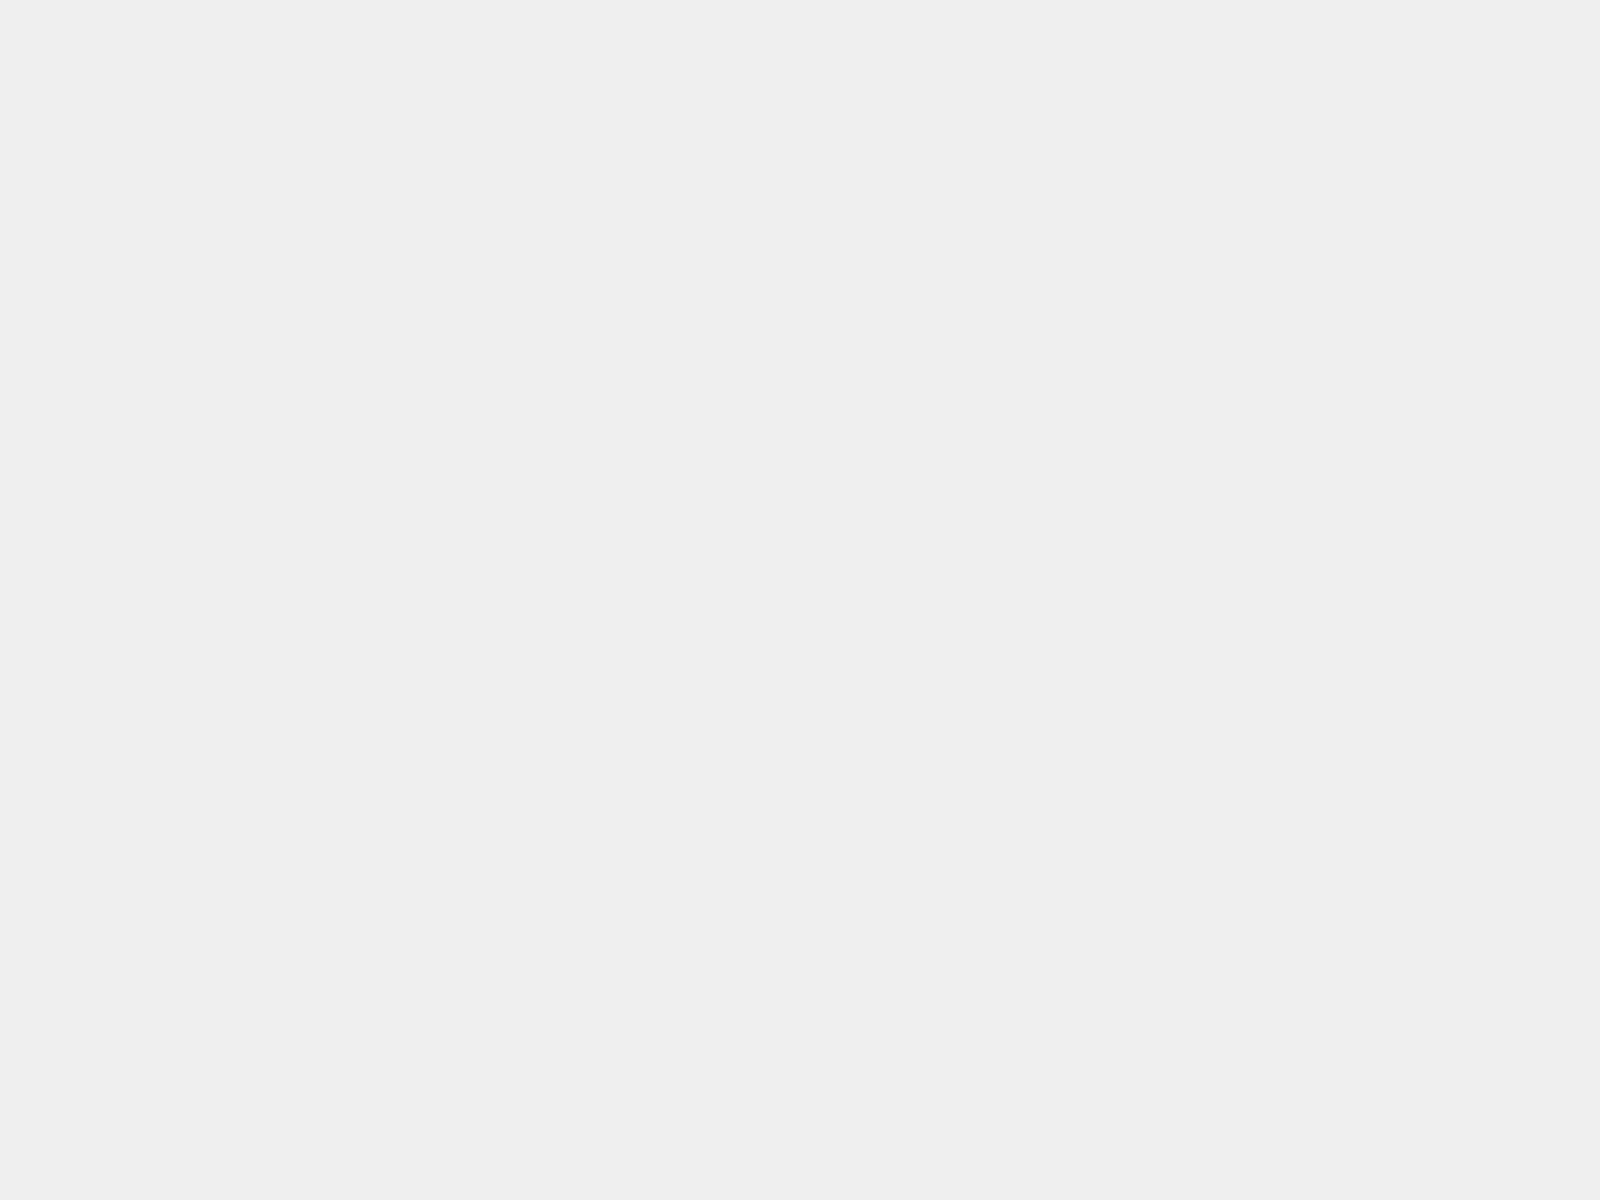Convert chart to OTSL. <chart><loc_0><loc_0><loc_500><loc_500><pie_chart><fcel>DISH Network awards held by<fcel>EchoStar awards held by DISH<fcel>Total<nl><fcel>41.56%<fcel>8.44%<fcel>50.0%<nl></chart> 